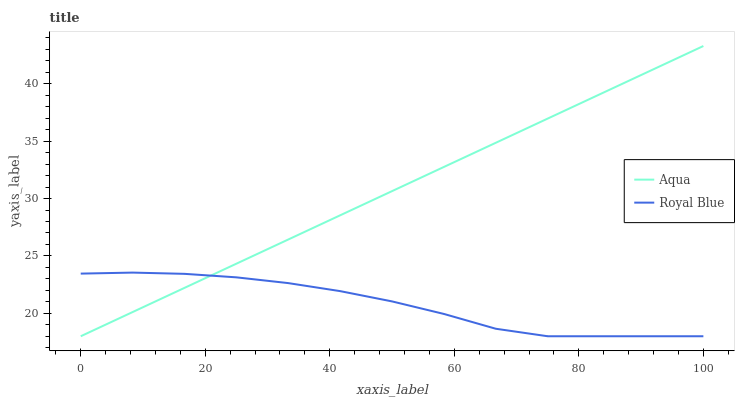Does Royal Blue have the minimum area under the curve?
Answer yes or no. Yes. Does Aqua have the maximum area under the curve?
Answer yes or no. Yes. Does Aqua have the minimum area under the curve?
Answer yes or no. No. Is Aqua the smoothest?
Answer yes or no. Yes. Is Royal Blue the roughest?
Answer yes or no. Yes. Is Aqua the roughest?
Answer yes or no. No. 